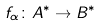<formula> <loc_0><loc_0><loc_500><loc_500>f _ { \alpha } \colon A ^ { \ast } \rightarrow B ^ { \ast }</formula> 